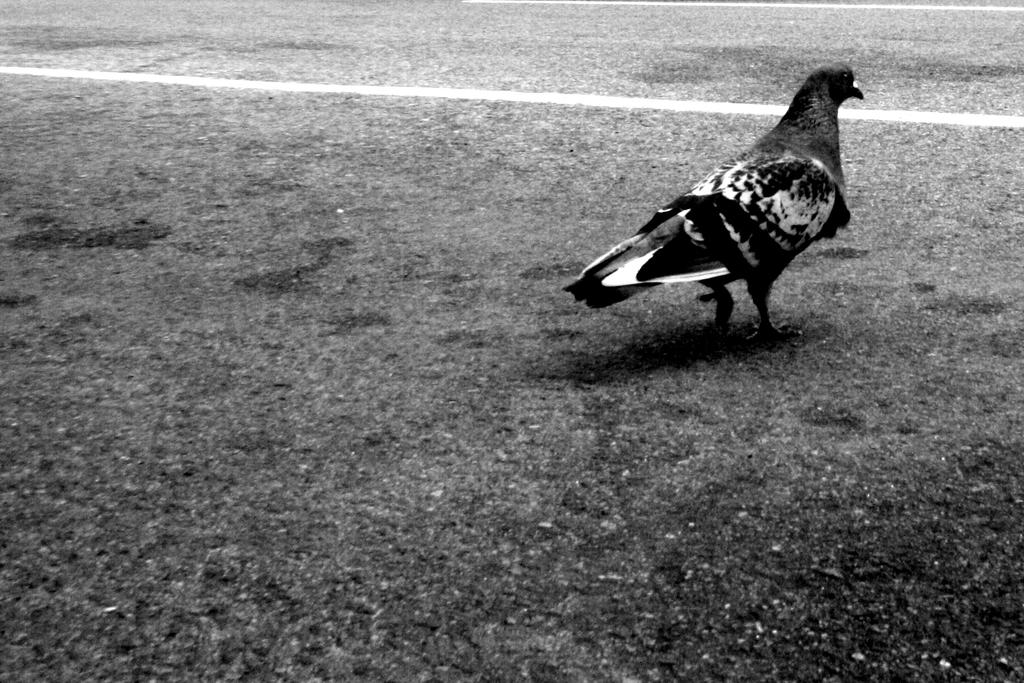What is the color scheme of the image? The image is black and white. What animal can be seen in the image? There is a dove in the image. Where is the dove located in the image? The dove is on the road and on the right side of the image. Is there a volcano erupting in the background of the image? No, there is no volcano present in the image. Can you see any jellyfish swimming in the road where the dove is located? No, there are no jellyfish in the image; it features a dove on the road in a black and white setting. 